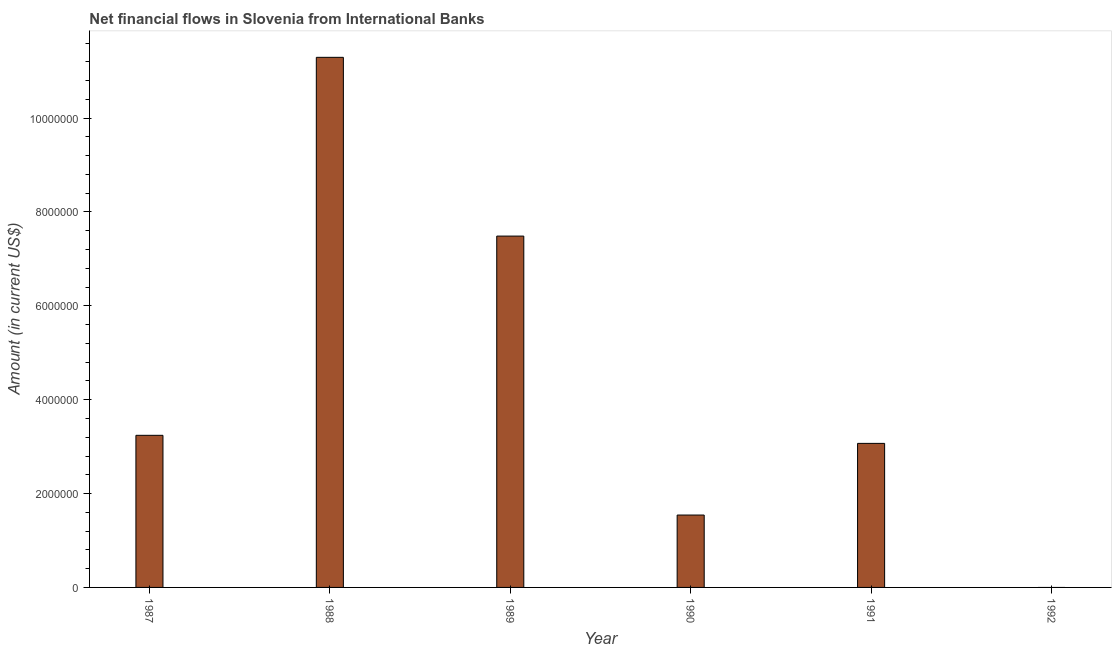What is the title of the graph?
Make the answer very short. Net financial flows in Slovenia from International Banks. What is the net financial flows from ibrd in 1987?
Provide a succinct answer. 3.24e+06. Across all years, what is the maximum net financial flows from ibrd?
Ensure brevity in your answer.  1.13e+07. What is the sum of the net financial flows from ibrd?
Offer a terse response. 2.66e+07. What is the difference between the net financial flows from ibrd in 1989 and 1991?
Keep it short and to the point. 4.42e+06. What is the average net financial flows from ibrd per year?
Give a very brief answer. 4.44e+06. What is the median net financial flows from ibrd?
Provide a succinct answer. 3.16e+06. What is the ratio of the net financial flows from ibrd in 1987 to that in 1989?
Provide a succinct answer. 0.43. Is the net financial flows from ibrd in 1987 less than that in 1989?
Provide a short and direct response. Yes. What is the difference between the highest and the second highest net financial flows from ibrd?
Your answer should be very brief. 3.81e+06. Is the sum of the net financial flows from ibrd in 1989 and 1991 greater than the maximum net financial flows from ibrd across all years?
Keep it short and to the point. No. What is the difference between the highest and the lowest net financial flows from ibrd?
Keep it short and to the point. 1.13e+07. How many bars are there?
Provide a succinct answer. 5. Are all the bars in the graph horizontal?
Keep it short and to the point. No. What is the difference between two consecutive major ticks on the Y-axis?
Provide a short and direct response. 2.00e+06. What is the Amount (in current US$) in 1987?
Give a very brief answer. 3.24e+06. What is the Amount (in current US$) of 1988?
Offer a terse response. 1.13e+07. What is the Amount (in current US$) of 1989?
Your answer should be compact. 7.49e+06. What is the Amount (in current US$) of 1990?
Your answer should be compact. 1.54e+06. What is the Amount (in current US$) of 1991?
Your answer should be very brief. 3.07e+06. What is the difference between the Amount (in current US$) in 1987 and 1988?
Keep it short and to the point. -8.05e+06. What is the difference between the Amount (in current US$) in 1987 and 1989?
Your answer should be very brief. -4.25e+06. What is the difference between the Amount (in current US$) in 1987 and 1990?
Ensure brevity in your answer.  1.70e+06. What is the difference between the Amount (in current US$) in 1987 and 1991?
Ensure brevity in your answer.  1.72e+05. What is the difference between the Amount (in current US$) in 1988 and 1989?
Offer a very short reply. 3.81e+06. What is the difference between the Amount (in current US$) in 1988 and 1990?
Make the answer very short. 9.75e+06. What is the difference between the Amount (in current US$) in 1988 and 1991?
Keep it short and to the point. 8.23e+06. What is the difference between the Amount (in current US$) in 1989 and 1990?
Offer a terse response. 5.94e+06. What is the difference between the Amount (in current US$) in 1989 and 1991?
Provide a short and direct response. 4.42e+06. What is the difference between the Amount (in current US$) in 1990 and 1991?
Keep it short and to the point. -1.53e+06. What is the ratio of the Amount (in current US$) in 1987 to that in 1988?
Your answer should be compact. 0.29. What is the ratio of the Amount (in current US$) in 1987 to that in 1989?
Provide a succinct answer. 0.43. What is the ratio of the Amount (in current US$) in 1987 to that in 1990?
Your answer should be compact. 2.1. What is the ratio of the Amount (in current US$) in 1987 to that in 1991?
Your answer should be compact. 1.06. What is the ratio of the Amount (in current US$) in 1988 to that in 1989?
Provide a short and direct response. 1.51. What is the ratio of the Amount (in current US$) in 1988 to that in 1990?
Provide a succinct answer. 7.32. What is the ratio of the Amount (in current US$) in 1988 to that in 1991?
Your response must be concise. 3.68. What is the ratio of the Amount (in current US$) in 1989 to that in 1990?
Your answer should be very brief. 4.85. What is the ratio of the Amount (in current US$) in 1989 to that in 1991?
Provide a short and direct response. 2.44. What is the ratio of the Amount (in current US$) in 1990 to that in 1991?
Offer a terse response. 0.5. 